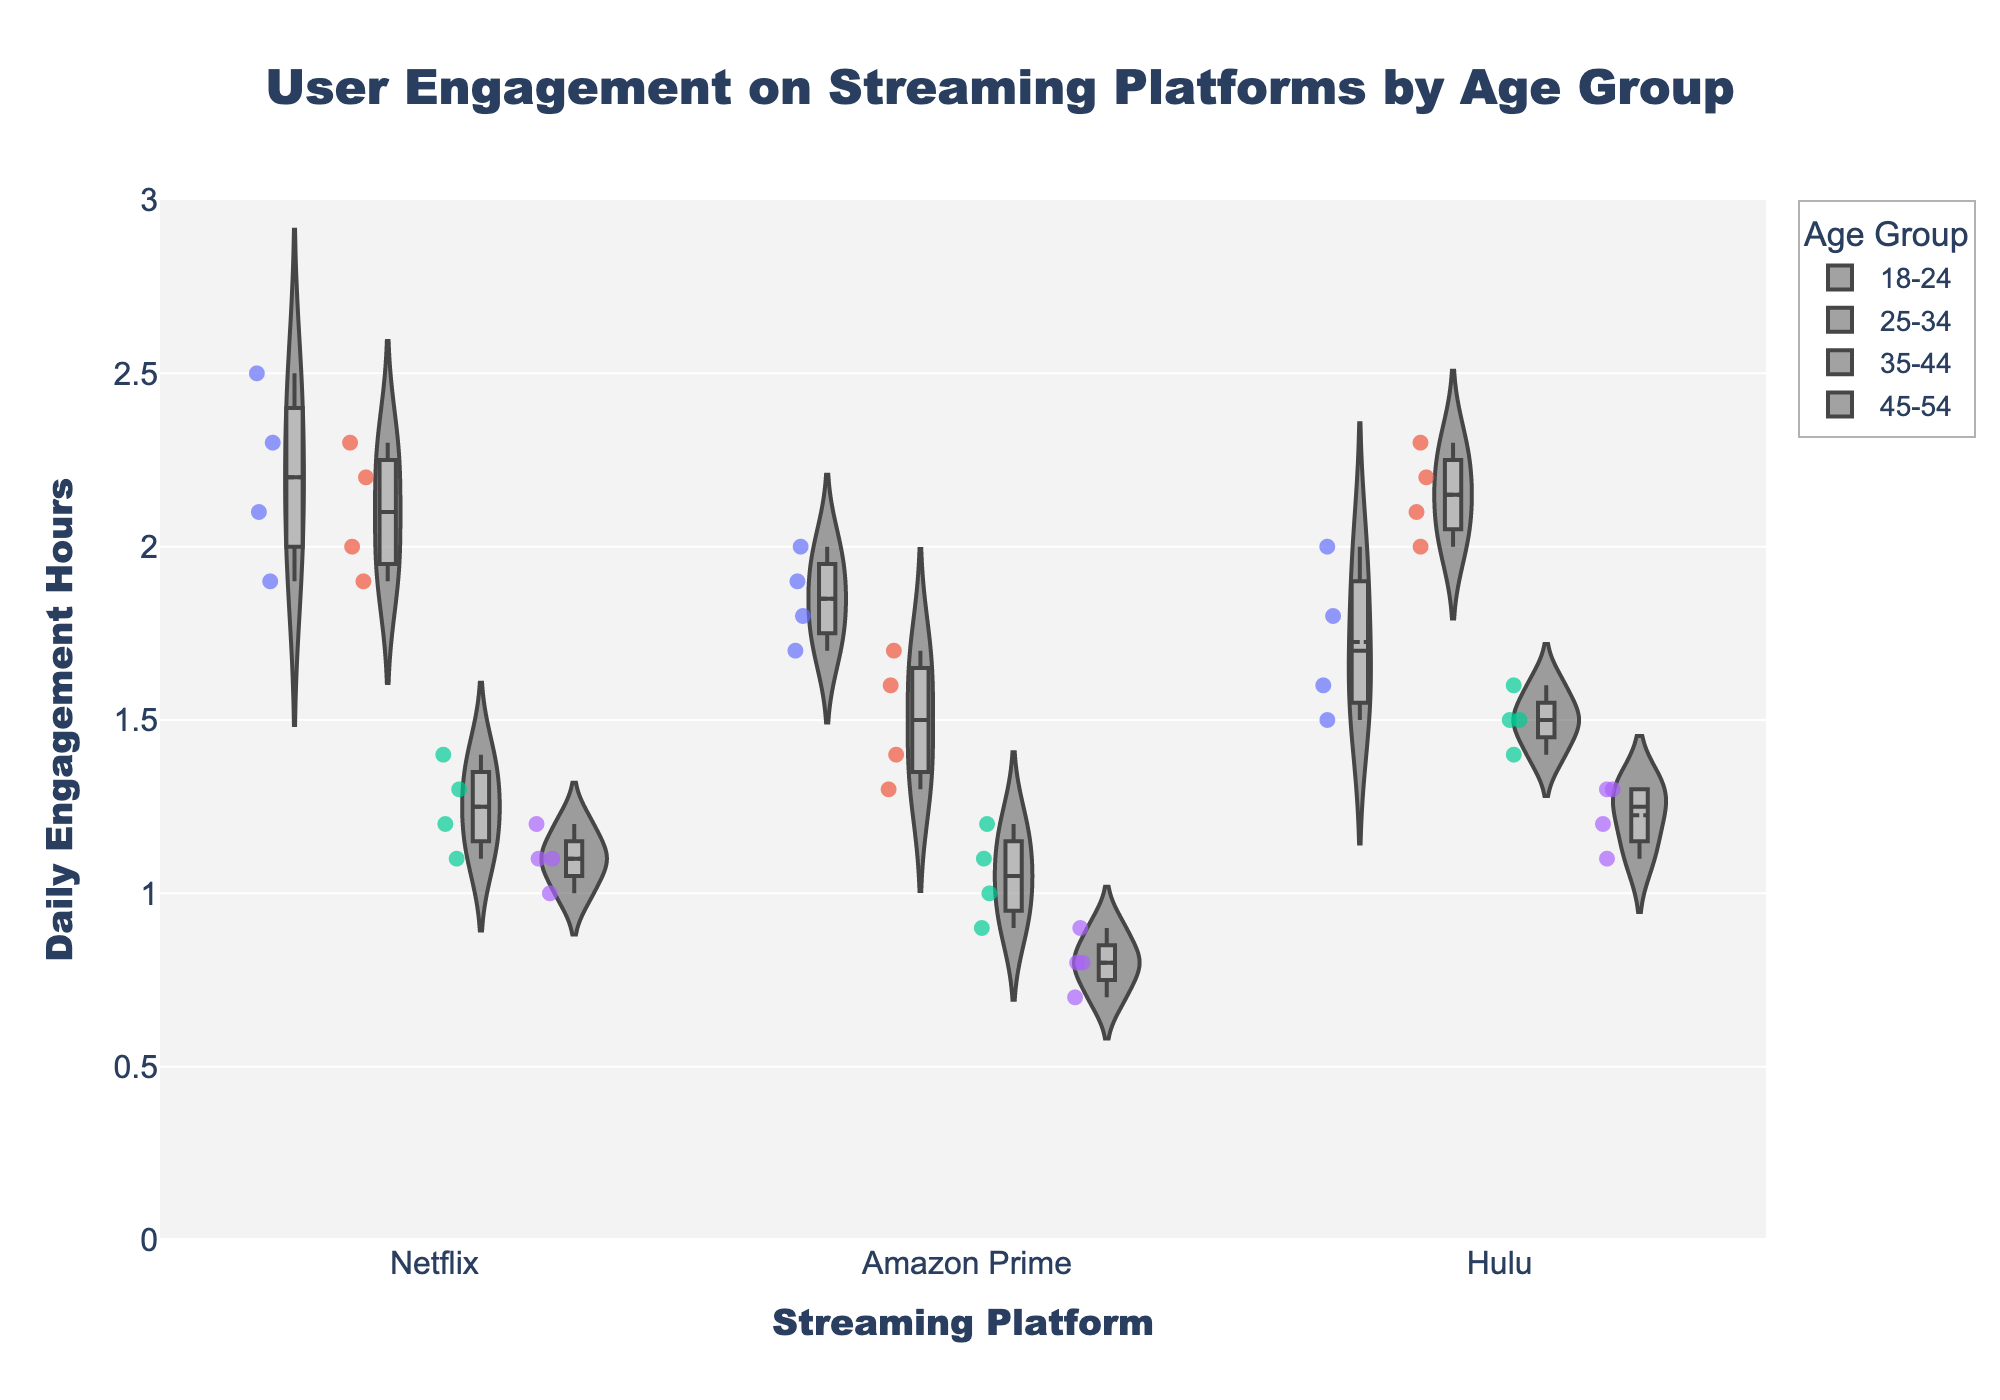What is the title of the figure? The title of the figure is usually positioned at the top and is distinct in font size and style. The title is clearly labeled at the top.
Answer: User Engagement on Streaming Platforms by Age Group Which streaming platform shows the highest engagement hours for the 25-34 age group? To identify the highest engagement hours for the 25-34 age group, look at the violin plots and jittered points for each streaming platform. Compare the highest points within each platform’s plot for the 25-34 age group.
Answer: Hulu How do the engagement hours of Netflix and Hulu compare for the 35-44 age group? Observe the distributions of the violin plots for Netflix and Hulu for the 35-44 age group. Compare the spread and central tendency (median/mean) of the points. Hulu shows generally higher daily engagement hours than Netflix.
Answer: Hulu has higher engagement What is the average engagement hours for Amazon Prime across all age groups? To find the average, look at all the jittered points for Amazon Prime across each age group, sum the individual engagement hours and divide by the total number of data points. Total engagement hours for Amazon Prime: 1.8+2.0+1.7+1.9+1.4+1.6+1.7+1.3+1.0+0.9+1.1+1.2+0.8+0.9+0.7+0.8 = 20.1. Number of data points: 16. Average = 20.1 / 16 = 1.26.
Answer: 1.26 Which age group shows the lowest median engagement on Netflix? Examine the position of the median line (usually marked inside the boxplot of the violin) for each age group within the Netflix category. The age group with the median line at the lowest position has the lowest median engagement.
Answer: 45-54 Are there any outliers in the engagement hours for Hulu in the 18-24 age group? Check for individual jittered points that are significantly distant from the main body of the violin plot or boxplot for the 18-24 age group in Hulu. Such points are considered outliers.
Answer: No How does the engagement distribution for Amazon Prime differ between the 18-24 and 25-34 age groups? Look at the shape and spread of the Amazon Prime violin plots for the 18-24 and 25-34 age groups. Compare the width, spread of the data points, and any significant differences in the median or range. The 18-24 age group has a slightly wider distribution and higher central tendency compared to the 25-34 age group.
Answer: 18-24 has a higher engagement What is the range of engagement hours for the 45-54 age group on any platform? The range is the difference between the highest and lowest engagement hours. For the 45-54 age group, examine the maximum and minimum jittered points within each violin plot. For instance, Netflix: 1.2-1.0, Amazon Prime: 0.9-0.7, Hulu: 1.3-1.1.
Answer: 0.6 (Hulu) 